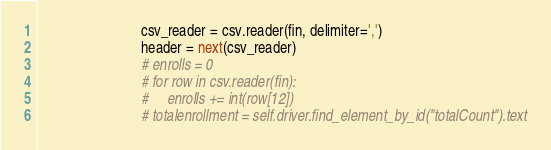Convert code to text. <code><loc_0><loc_0><loc_500><loc_500><_Python_>                            csv_reader = csv.reader(fin, delimiter=',')
                            header = next(csv_reader)
                            # enrolls = 0
                            # for row in csv.reader(fin):
                            #     enrolls += int(row[12])
                            # totalenrollment = self.driver.find_element_by_id("totalCount").text</code> 